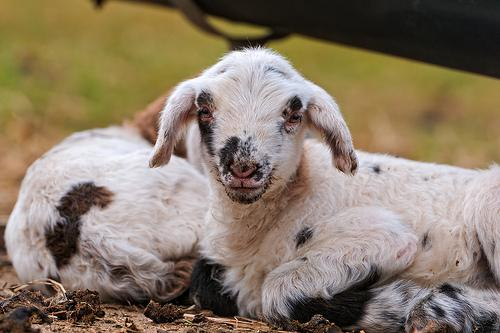Provide a brief overview of the primary subject in the image. A baby goat with black and white spots is lying on the ground surrounded by green grass, dirt, and hay. Describe the appearance and surroundings of the primary subject in the image. A black and white baby goat with a brown spot is lying on the ground, surrounded by grass, dirt, and hay. Mention the main animal in the image and its location. A baby goat is positioned on the ground, surrounded by a mix of green grass, dirt, and hay. Describe the main object's head features in the image. The goat's head has two eyes, a pink and black nose, a mouth, and two ears, with one of the eyes surrounded by a black spot. Write a description of the main subject's legs in the image. The image includes the leg of a baby goat visible as it lies on the ground with a mixture of grass, dirt, and hay around it. Briefly describe the ground where the main subject is lying. The baby goat is lying on a mixture of green grass, dirt, and hay scattered on the ground. Provide an overview of the goat's facial features in the image. The goat's face includes two eyes, two ears, a pink and black nose, and a mouth, with a black spot around one eye. Summarize the image content, highlighting the goat's face. The image features a baby goat's face with black and white colors, a black spot around one eye, and pink and black nose, lying on the ground. Write a brief description of the scene, focusing on the main subject. The image shows a baby goat with black and white spots, brown spot, laying on a mixture of green grass, dirt, and hay. Identify the primary subject and describe its coloration. The main subject is a baby goat with black and white colors and a brown spot lying on the ground. 